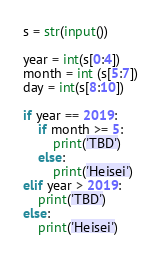<code> <loc_0><loc_0><loc_500><loc_500><_Python_>s = str(input())

year = int(s[0:4])
month = int (s[5:7])
day = int(s[8:10])

if year == 2019:
    if month >= 5:
        print('TBD')
    else:
        print('Heisei')
elif year > 2019:
    print('TBD')
else:
    print('Heisei')</code> 